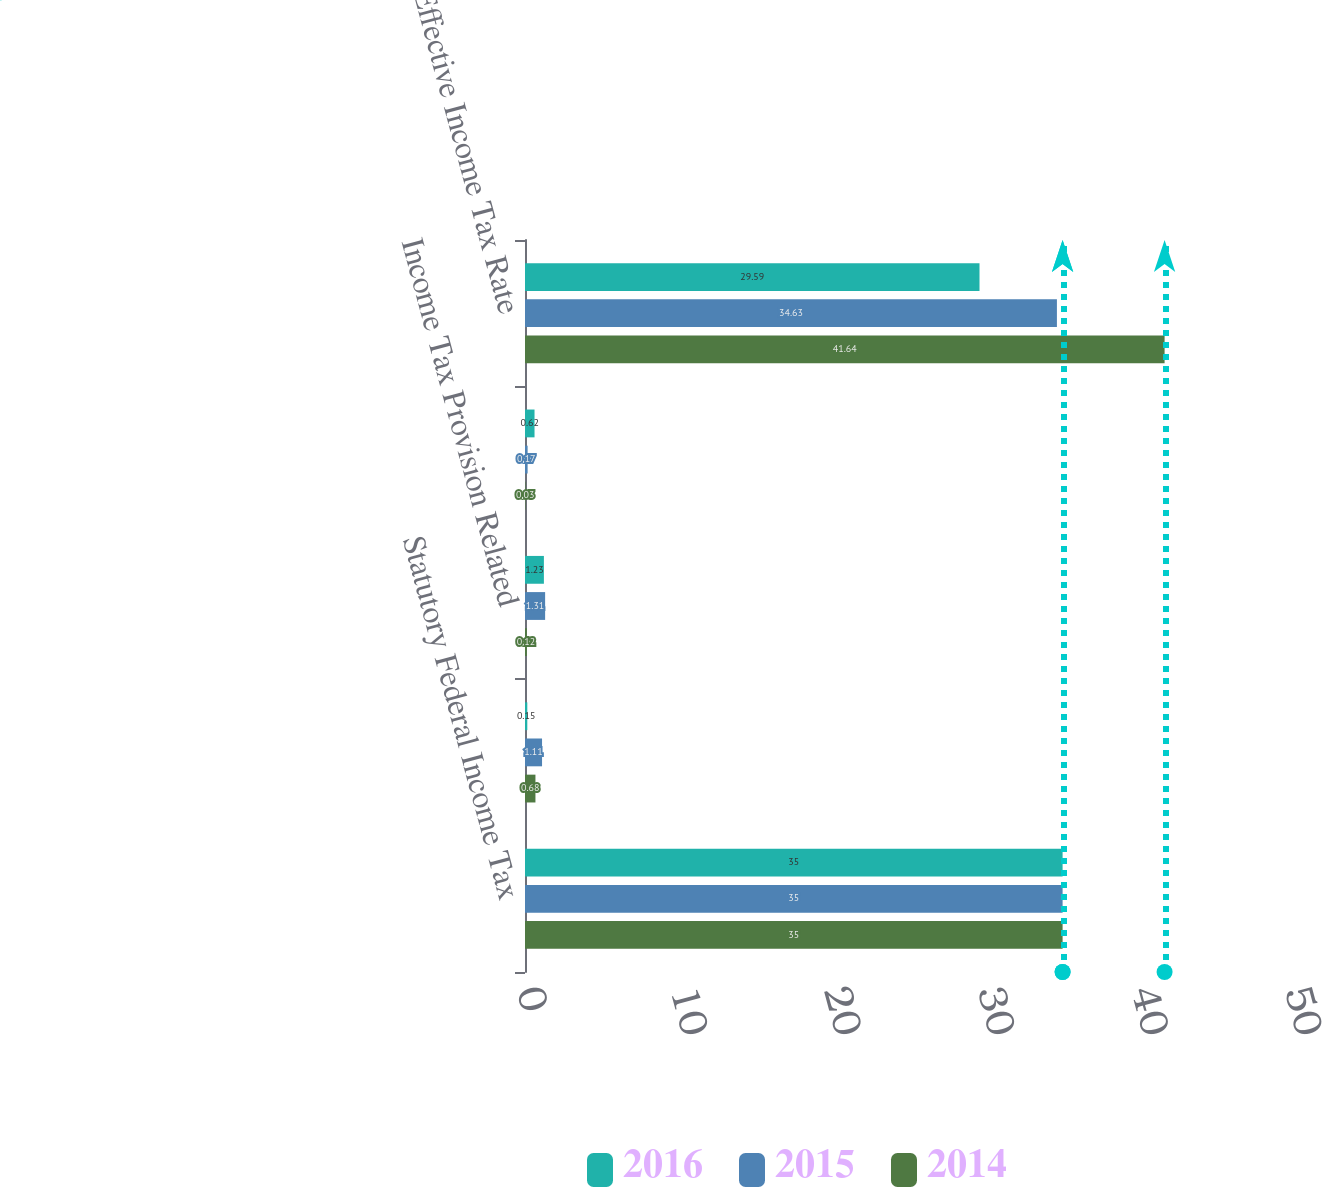Convert chart. <chart><loc_0><loc_0><loc_500><loc_500><stacked_bar_chart><ecel><fcel>Statutory Federal Income Tax<fcel>State Income Tax Net of<fcel>Income Tax Provision Related<fcel>Other<fcel>Effective Income Tax Rate<nl><fcel>2016<fcel>35<fcel>0.15<fcel>1.23<fcel>0.62<fcel>29.59<nl><fcel>2015<fcel>35<fcel>1.11<fcel>1.31<fcel>0.17<fcel>34.63<nl><fcel>2014<fcel>35<fcel>0.68<fcel>0.12<fcel>0.03<fcel>41.64<nl></chart> 